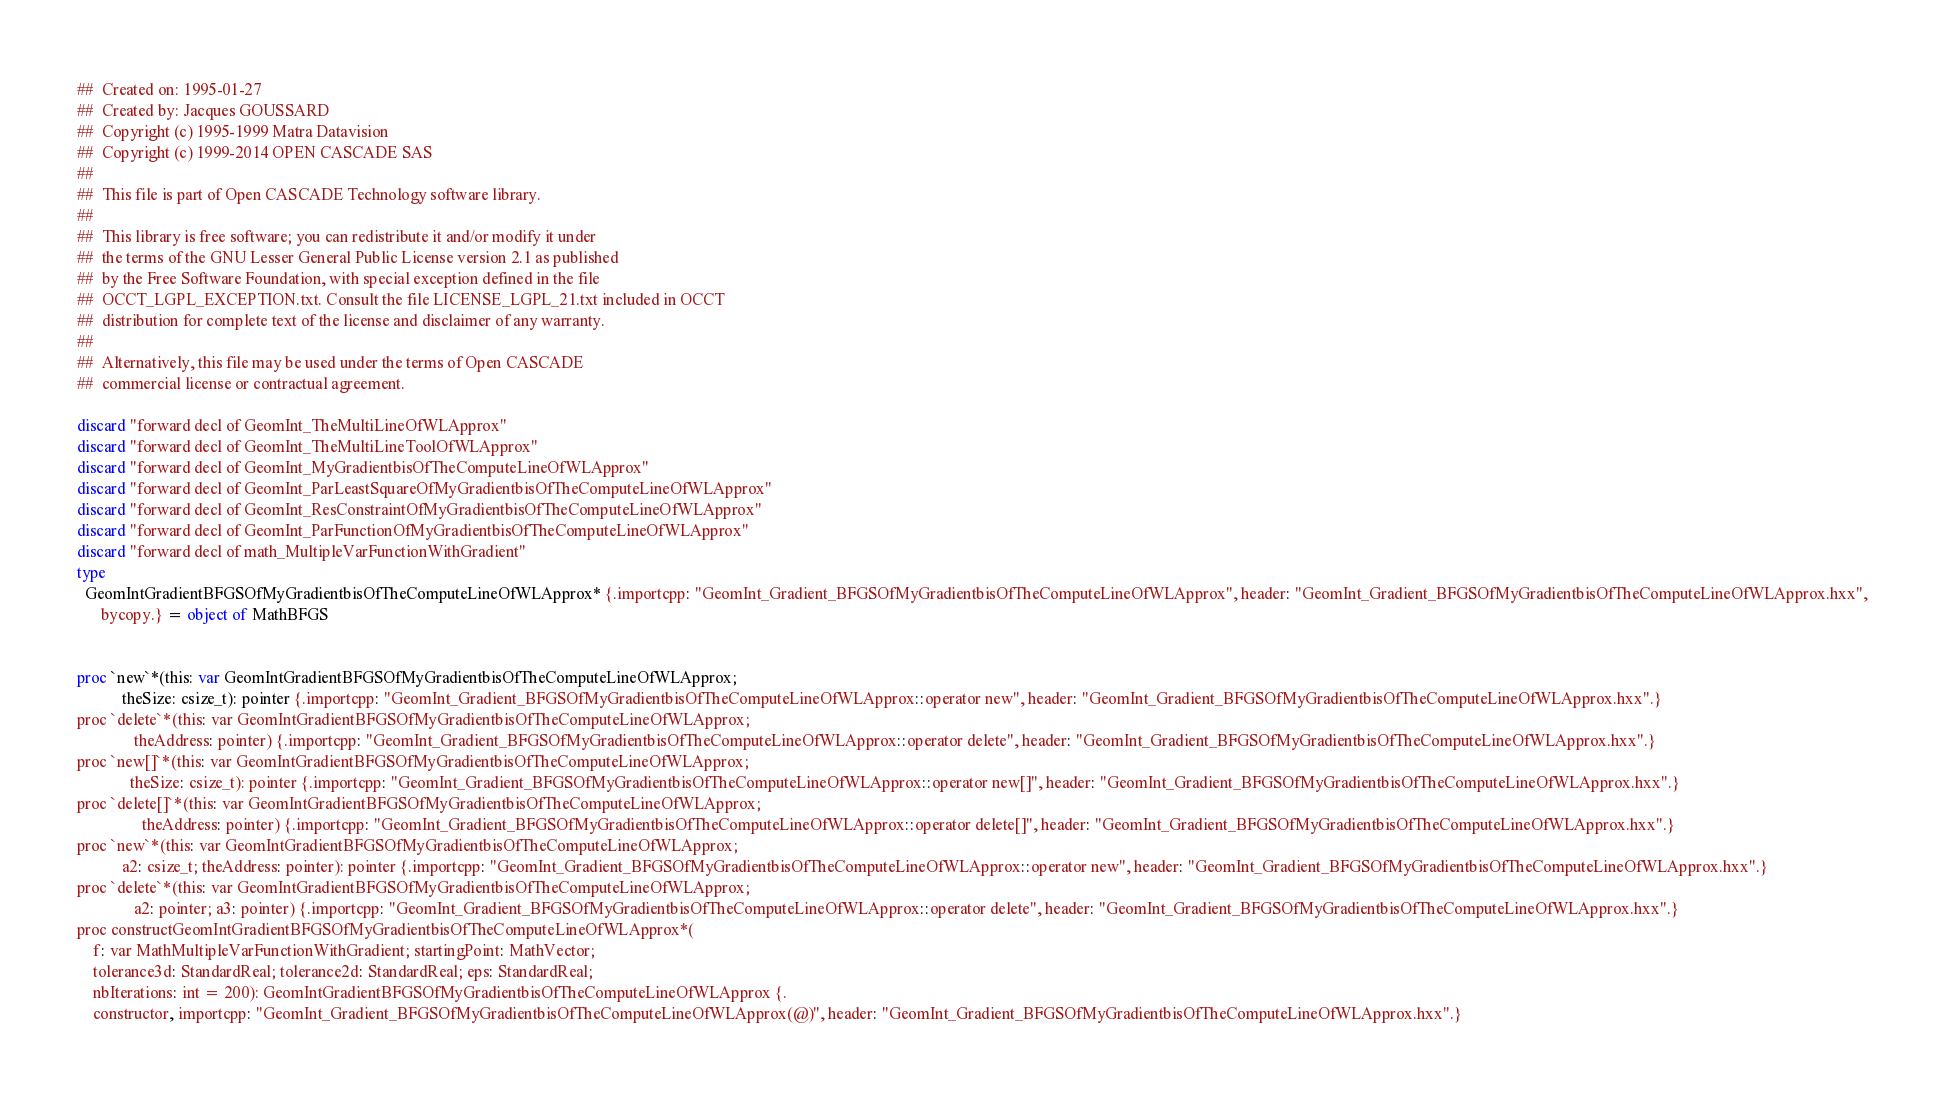Convert code to text. <code><loc_0><loc_0><loc_500><loc_500><_Nim_>##  Created on: 1995-01-27
##  Created by: Jacques GOUSSARD
##  Copyright (c) 1995-1999 Matra Datavision
##  Copyright (c) 1999-2014 OPEN CASCADE SAS
##
##  This file is part of Open CASCADE Technology software library.
##
##  This library is free software; you can redistribute it and/or modify it under
##  the terms of the GNU Lesser General Public License version 2.1 as published
##  by the Free Software Foundation, with special exception defined in the file
##  OCCT_LGPL_EXCEPTION.txt. Consult the file LICENSE_LGPL_21.txt included in OCCT
##  distribution for complete text of the license and disclaimer of any warranty.
##
##  Alternatively, this file may be used under the terms of Open CASCADE
##  commercial license or contractual agreement.

discard "forward decl of GeomInt_TheMultiLineOfWLApprox"
discard "forward decl of GeomInt_TheMultiLineToolOfWLApprox"
discard "forward decl of GeomInt_MyGradientbisOfTheComputeLineOfWLApprox"
discard "forward decl of GeomInt_ParLeastSquareOfMyGradientbisOfTheComputeLineOfWLApprox"
discard "forward decl of GeomInt_ResConstraintOfMyGradientbisOfTheComputeLineOfWLApprox"
discard "forward decl of GeomInt_ParFunctionOfMyGradientbisOfTheComputeLineOfWLApprox"
discard "forward decl of math_MultipleVarFunctionWithGradient"
type
  GeomIntGradientBFGSOfMyGradientbisOfTheComputeLineOfWLApprox* {.importcpp: "GeomInt_Gradient_BFGSOfMyGradientbisOfTheComputeLineOfWLApprox", header: "GeomInt_Gradient_BFGSOfMyGradientbisOfTheComputeLineOfWLApprox.hxx",
      bycopy.} = object of MathBFGS


proc `new`*(this: var GeomIntGradientBFGSOfMyGradientbisOfTheComputeLineOfWLApprox;
           theSize: csize_t): pointer {.importcpp: "GeomInt_Gradient_BFGSOfMyGradientbisOfTheComputeLineOfWLApprox::operator new", header: "GeomInt_Gradient_BFGSOfMyGradientbisOfTheComputeLineOfWLApprox.hxx".}
proc `delete`*(this: var GeomIntGradientBFGSOfMyGradientbisOfTheComputeLineOfWLApprox;
              theAddress: pointer) {.importcpp: "GeomInt_Gradient_BFGSOfMyGradientbisOfTheComputeLineOfWLApprox::operator delete", header: "GeomInt_Gradient_BFGSOfMyGradientbisOfTheComputeLineOfWLApprox.hxx".}
proc `new[]`*(this: var GeomIntGradientBFGSOfMyGradientbisOfTheComputeLineOfWLApprox;
             theSize: csize_t): pointer {.importcpp: "GeomInt_Gradient_BFGSOfMyGradientbisOfTheComputeLineOfWLApprox::operator new[]", header: "GeomInt_Gradient_BFGSOfMyGradientbisOfTheComputeLineOfWLApprox.hxx".}
proc `delete[]`*(this: var GeomIntGradientBFGSOfMyGradientbisOfTheComputeLineOfWLApprox;
                theAddress: pointer) {.importcpp: "GeomInt_Gradient_BFGSOfMyGradientbisOfTheComputeLineOfWLApprox::operator delete[]", header: "GeomInt_Gradient_BFGSOfMyGradientbisOfTheComputeLineOfWLApprox.hxx".}
proc `new`*(this: var GeomIntGradientBFGSOfMyGradientbisOfTheComputeLineOfWLApprox;
           a2: csize_t; theAddress: pointer): pointer {.importcpp: "GeomInt_Gradient_BFGSOfMyGradientbisOfTheComputeLineOfWLApprox::operator new", header: "GeomInt_Gradient_BFGSOfMyGradientbisOfTheComputeLineOfWLApprox.hxx".}
proc `delete`*(this: var GeomIntGradientBFGSOfMyGradientbisOfTheComputeLineOfWLApprox;
              a2: pointer; a3: pointer) {.importcpp: "GeomInt_Gradient_BFGSOfMyGradientbisOfTheComputeLineOfWLApprox::operator delete", header: "GeomInt_Gradient_BFGSOfMyGradientbisOfTheComputeLineOfWLApprox.hxx".}
proc constructGeomIntGradientBFGSOfMyGradientbisOfTheComputeLineOfWLApprox*(
    f: var MathMultipleVarFunctionWithGradient; startingPoint: MathVector;
    tolerance3d: StandardReal; tolerance2d: StandardReal; eps: StandardReal;
    nbIterations: int = 200): GeomIntGradientBFGSOfMyGradientbisOfTheComputeLineOfWLApprox {.
    constructor, importcpp: "GeomInt_Gradient_BFGSOfMyGradientbisOfTheComputeLineOfWLApprox(@)", header: "GeomInt_Gradient_BFGSOfMyGradientbisOfTheComputeLineOfWLApprox.hxx".}</code> 